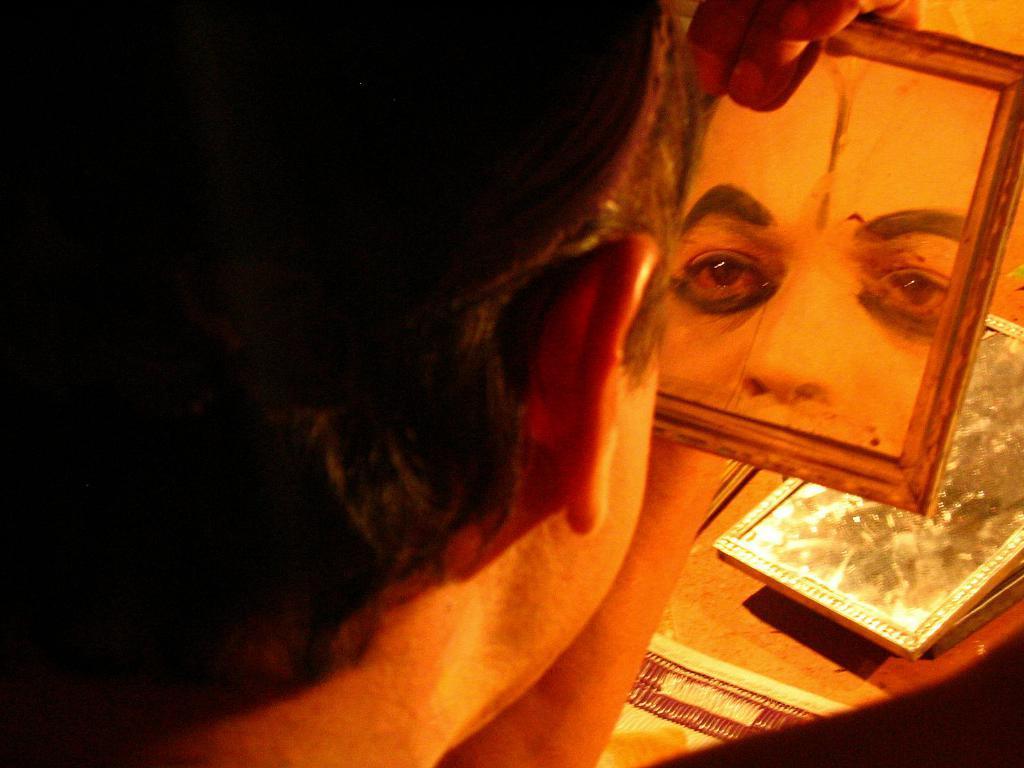Describe this image in one or two sentences. In this image I can see a man and I can see he is holding a mirror. I can also see reflection of his face on the mirror. On the bottom right side of this image I can see one more mirror. 